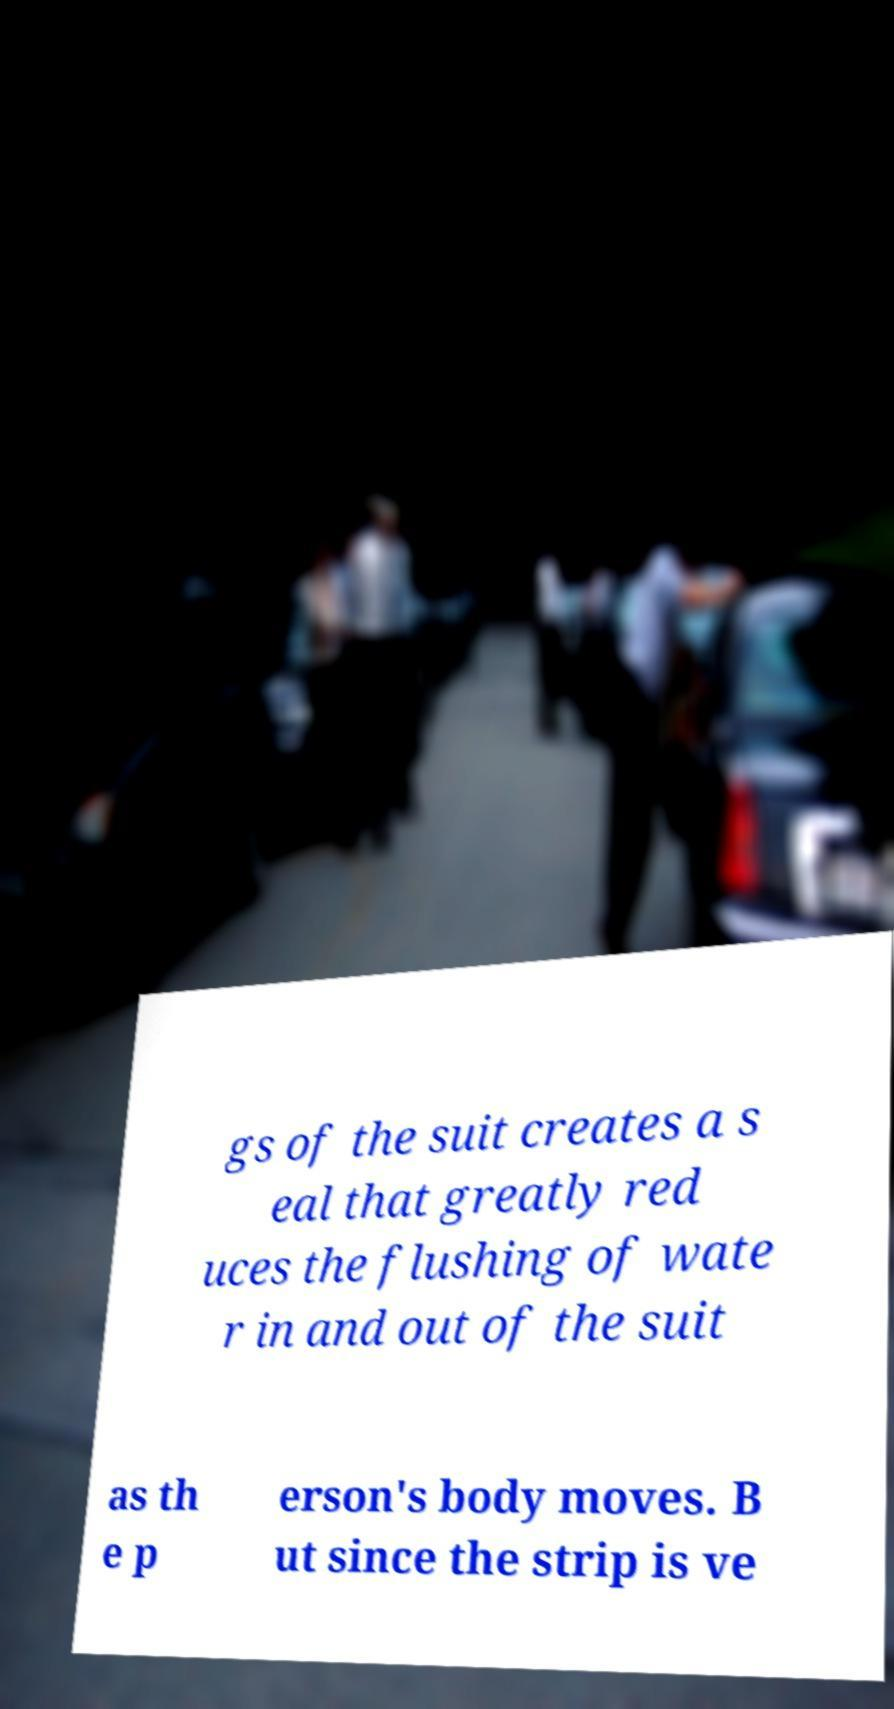There's text embedded in this image that I need extracted. Can you transcribe it verbatim? gs of the suit creates a s eal that greatly red uces the flushing of wate r in and out of the suit as th e p erson's body moves. B ut since the strip is ve 